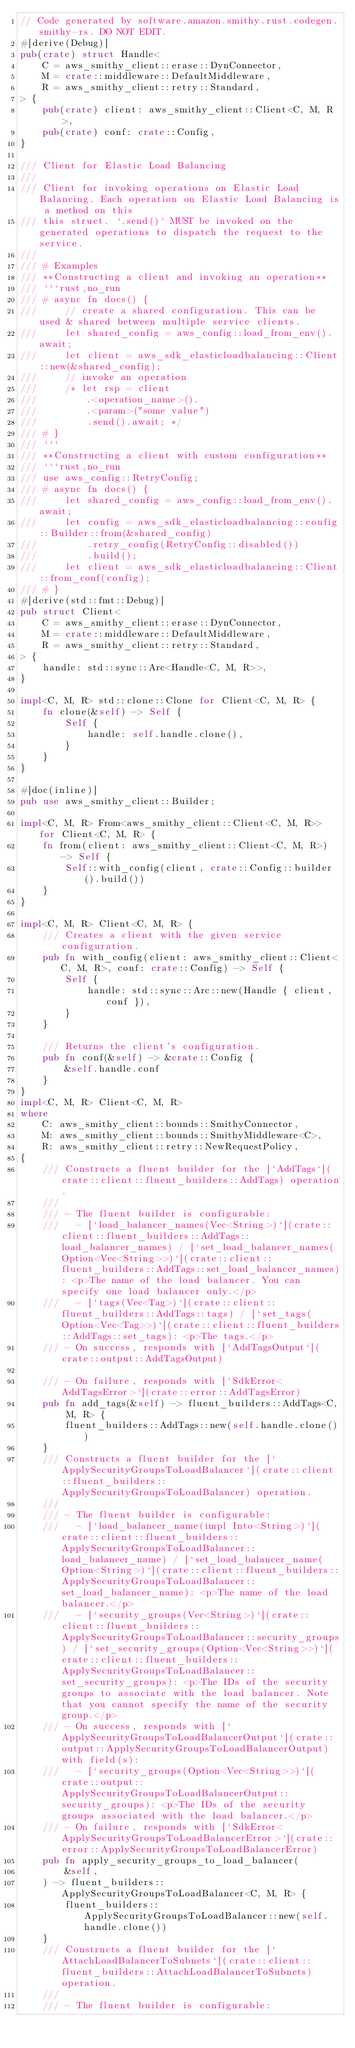<code> <loc_0><loc_0><loc_500><loc_500><_Rust_>// Code generated by software.amazon.smithy.rust.codegen.smithy-rs. DO NOT EDIT.
#[derive(Debug)]
pub(crate) struct Handle<
    C = aws_smithy_client::erase::DynConnector,
    M = crate::middleware::DefaultMiddleware,
    R = aws_smithy_client::retry::Standard,
> {
    pub(crate) client: aws_smithy_client::Client<C, M, R>,
    pub(crate) conf: crate::Config,
}

/// Client for Elastic Load Balancing
///
/// Client for invoking operations on Elastic Load Balancing. Each operation on Elastic Load Balancing is a method on this
/// this struct. `.send()` MUST be invoked on the generated operations to dispatch the request to the service.
///
/// # Examples
/// **Constructing a client and invoking an operation**
/// ```rust,no_run
/// # async fn docs() {
///     // create a shared configuration. This can be used & shared between multiple service clients.
///     let shared_config = aws_config::load_from_env().await;
///     let client = aws_sdk_elasticloadbalancing::Client::new(&shared_config);
///     // invoke an operation
///     /* let rsp = client
///         .<operation_name>().
///         .<param>("some value")
///         .send().await; */
/// # }
/// ```
/// **Constructing a client with custom configuration**
/// ```rust,no_run
/// use aws_config::RetryConfig;
/// # async fn docs() {
///     let shared_config = aws_config::load_from_env().await;
///     let config = aws_sdk_elasticloadbalancing::config::Builder::from(&shared_config)
///         .retry_config(RetryConfig::disabled())
///         .build();
///     let client = aws_sdk_elasticloadbalancing::Client::from_conf(config);
/// # }
#[derive(std::fmt::Debug)]
pub struct Client<
    C = aws_smithy_client::erase::DynConnector,
    M = crate::middleware::DefaultMiddleware,
    R = aws_smithy_client::retry::Standard,
> {
    handle: std::sync::Arc<Handle<C, M, R>>,
}

impl<C, M, R> std::clone::Clone for Client<C, M, R> {
    fn clone(&self) -> Self {
        Self {
            handle: self.handle.clone(),
        }
    }
}

#[doc(inline)]
pub use aws_smithy_client::Builder;

impl<C, M, R> From<aws_smithy_client::Client<C, M, R>> for Client<C, M, R> {
    fn from(client: aws_smithy_client::Client<C, M, R>) -> Self {
        Self::with_config(client, crate::Config::builder().build())
    }
}

impl<C, M, R> Client<C, M, R> {
    /// Creates a client with the given service configuration.
    pub fn with_config(client: aws_smithy_client::Client<C, M, R>, conf: crate::Config) -> Self {
        Self {
            handle: std::sync::Arc::new(Handle { client, conf }),
        }
    }

    /// Returns the client's configuration.
    pub fn conf(&self) -> &crate::Config {
        &self.handle.conf
    }
}
impl<C, M, R> Client<C, M, R>
where
    C: aws_smithy_client::bounds::SmithyConnector,
    M: aws_smithy_client::bounds::SmithyMiddleware<C>,
    R: aws_smithy_client::retry::NewRequestPolicy,
{
    /// Constructs a fluent builder for the [`AddTags`](crate::client::fluent_builders::AddTags) operation.
    ///
    /// - The fluent builder is configurable:
    ///   - [`load_balancer_names(Vec<String>)`](crate::client::fluent_builders::AddTags::load_balancer_names) / [`set_load_balancer_names(Option<Vec<String>>)`](crate::client::fluent_builders::AddTags::set_load_balancer_names): <p>The name of the load balancer. You can specify one load balancer only.</p>
    ///   - [`tags(Vec<Tag>)`](crate::client::fluent_builders::AddTags::tags) / [`set_tags(Option<Vec<Tag>>)`](crate::client::fluent_builders::AddTags::set_tags): <p>The tags.</p>
    /// - On success, responds with [`AddTagsOutput`](crate::output::AddTagsOutput)

    /// - On failure, responds with [`SdkError<AddTagsError>`](crate::error::AddTagsError)
    pub fn add_tags(&self) -> fluent_builders::AddTags<C, M, R> {
        fluent_builders::AddTags::new(self.handle.clone())
    }
    /// Constructs a fluent builder for the [`ApplySecurityGroupsToLoadBalancer`](crate::client::fluent_builders::ApplySecurityGroupsToLoadBalancer) operation.
    ///
    /// - The fluent builder is configurable:
    ///   - [`load_balancer_name(impl Into<String>)`](crate::client::fluent_builders::ApplySecurityGroupsToLoadBalancer::load_balancer_name) / [`set_load_balancer_name(Option<String>)`](crate::client::fluent_builders::ApplySecurityGroupsToLoadBalancer::set_load_balancer_name): <p>The name of the load balancer.</p>
    ///   - [`security_groups(Vec<String>)`](crate::client::fluent_builders::ApplySecurityGroupsToLoadBalancer::security_groups) / [`set_security_groups(Option<Vec<String>>)`](crate::client::fluent_builders::ApplySecurityGroupsToLoadBalancer::set_security_groups): <p>The IDs of the security groups to associate with the load balancer. Note that you cannot specify the name of the security group.</p>
    /// - On success, responds with [`ApplySecurityGroupsToLoadBalancerOutput`](crate::output::ApplySecurityGroupsToLoadBalancerOutput) with field(s):
    ///   - [`security_groups(Option<Vec<String>>)`](crate::output::ApplySecurityGroupsToLoadBalancerOutput::security_groups): <p>The IDs of the security groups associated with the load balancer.</p>
    /// - On failure, responds with [`SdkError<ApplySecurityGroupsToLoadBalancerError>`](crate::error::ApplySecurityGroupsToLoadBalancerError)
    pub fn apply_security_groups_to_load_balancer(
        &self,
    ) -> fluent_builders::ApplySecurityGroupsToLoadBalancer<C, M, R> {
        fluent_builders::ApplySecurityGroupsToLoadBalancer::new(self.handle.clone())
    }
    /// Constructs a fluent builder for the [`AttachLoadBalancerToSubnets`](crate::client::fluent_builders::AttachLoadBalancerToSubnets) operation.
    ///
    /// - The fluent builder is configurable:</code> 